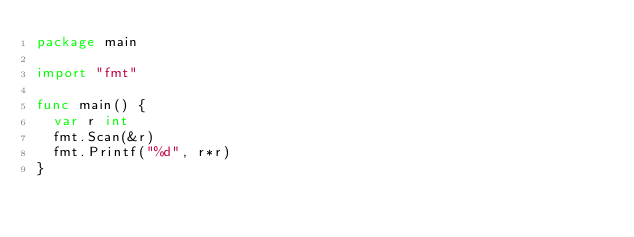Convert code to text. <code><loc_0><loc_0><loc_500><loc_500><_Go_>package main

import "fmt"

func main() {
  var r int
  fmt.Scan(&r)
  fmt.Printf("%d", r*r)
}</code> 